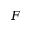<formula> <loc_0><loc_0><loc_500><loc_500>F</formula> 